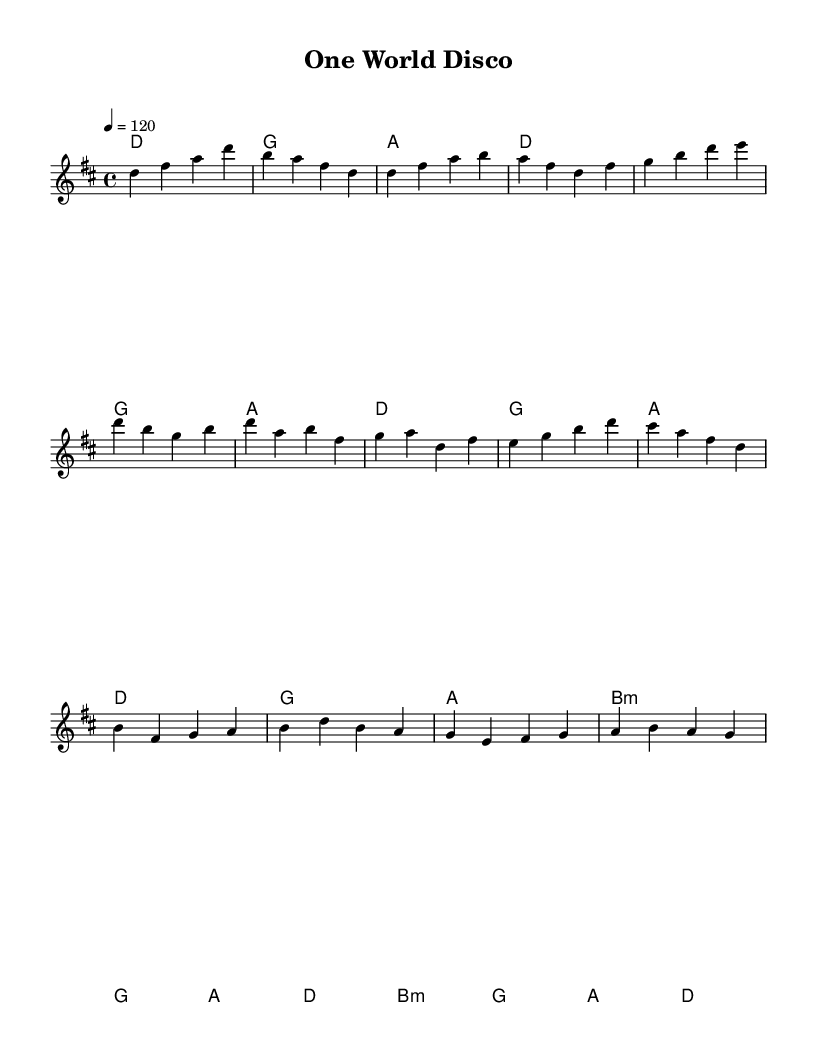What is the key signature of this music? The key signature is D major, which has two sharps (F# and C#). This can be identified from the key signature at the beginning of the score.
Answer: D major What is the time signature of this piece? The time signature is 4/4, indicating that there are four beats in each measure and a quarter note receives one beat. This is shown at the beginning of the music notation.
Answer: 4/4 What is the tempo marking for this piece? The tempo marking is 120 beats per minute, indicated by the tempo indication written at the start of the score as "4 = 120".
Answer: 120 How many measures are in the verse section of the music? The verse section consists of two phrases with four measures each, totaling eight measures. This can be counted by examining the composed melody and harmonies of the verse section.
Answer: 8 What chord is played in the chorus at the start? The first chord in the chorus is D major, as indicated in the chord symbols above the melody, showing that D is the chord played at the beginning of the chorus.
Answer: D What is the rhythmic structure like in the bridge section? The rhythmic structure in the bridge is consistent, primarily alternating between quarter notes and half notes, contributing to the driving disco beat characteristic of this genre. This can be seen by analyzing the note values in the bridge part of the melody.
Answer: Alternating quarter and half notes Which musical sections are repeated in this composition? The chorus section repeats in the composition, which is highlighted by similar melodic and harmonic material across the different choruses. This observation comes from analyzing the repeated motifs in the melody and chords throughout.
Answer: Chorus 